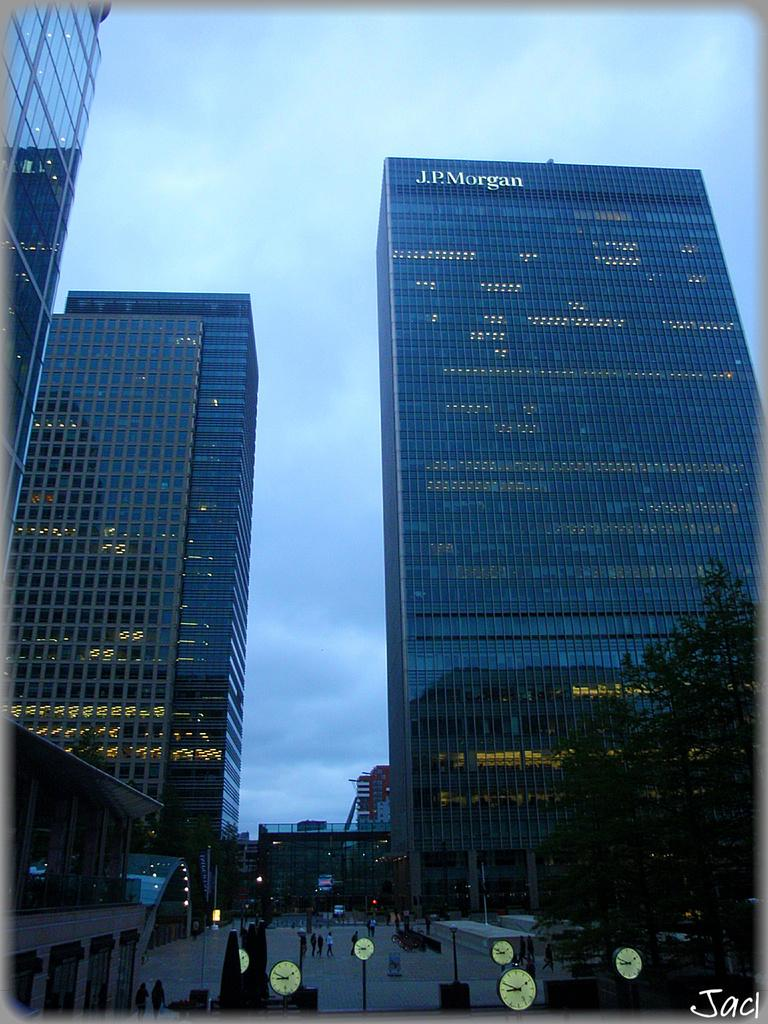What type of structures are present in the image? There are buildings in the image. What can be seen in front of the buildings? There are people, clock poles, and a tree in front of the buildings. What is the condition of the sky in the image? The sky is cloudy in the image. Is there any text or logo visible in the image? Yes, there is a watermark in the image. What type of windows do the buildings have? The buildings have glass windows. How many legs can be seen on the people in the image? The question about the number of legs is irrelevant, as the focus should be on the visible elements in the image, not the anatomy of the people. 